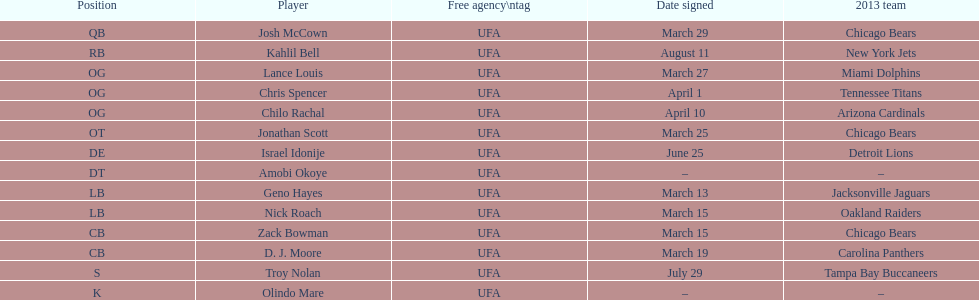Signed on the same date as april fools' day. Chris Spencer. 